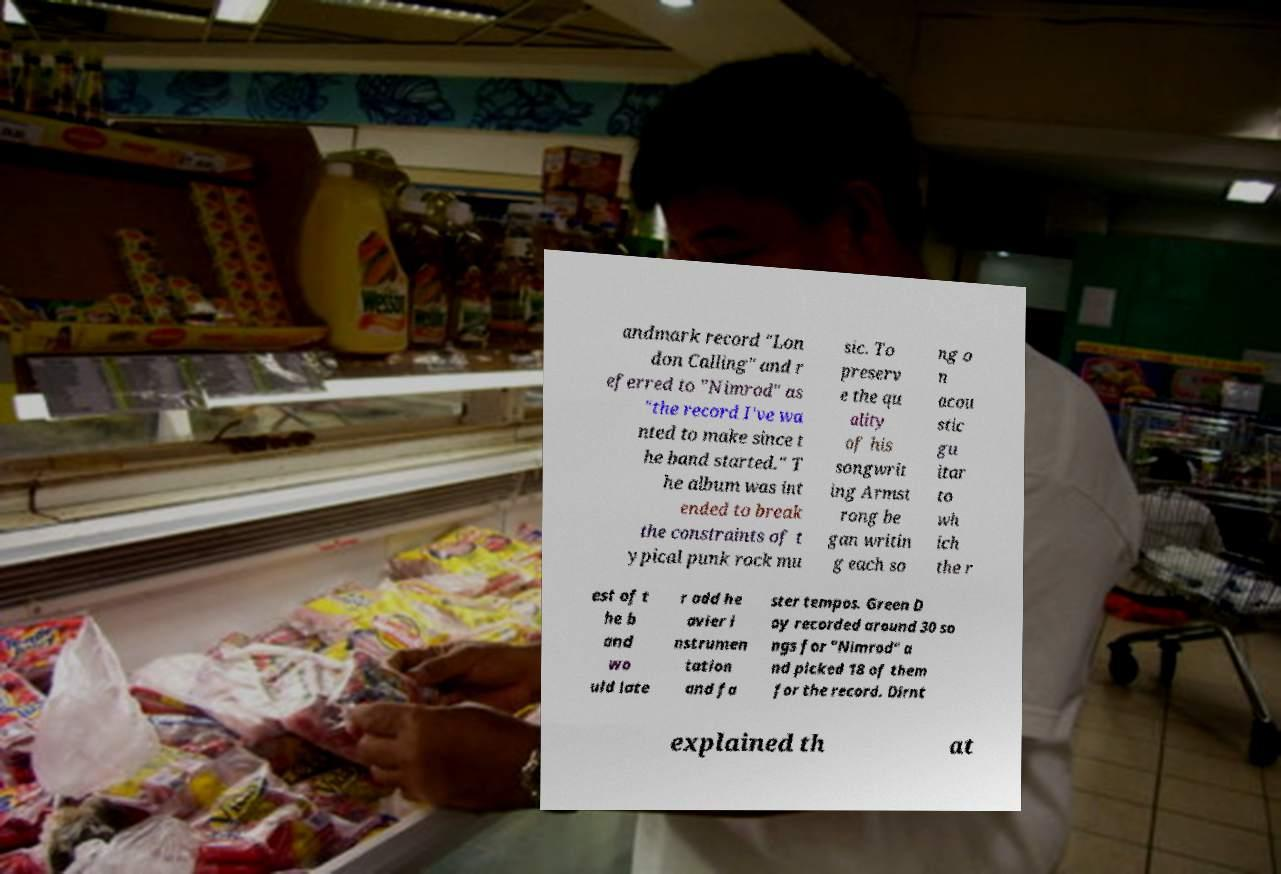Can you accurately transcribe the text from the provided image for me? andmark record "Lon don Calling" and r eferred to "Nimrod" as "the record I've wa nted to make since t he band started." T he album was int ended to break the constraints of t ypical punk rock mu sic. To preserv e the qu ality of his songwrit ing Armst rong be gan writin g each so ng o n acou stic gu itar to wh ich the r est of t he b and wo uld late r add he avier i nstrumen tation and fa ster tempos. Green D ay recorded around 30 so ngs for "Nimrod" a nd picked 18 of them for the record. Dirnt explained th at 